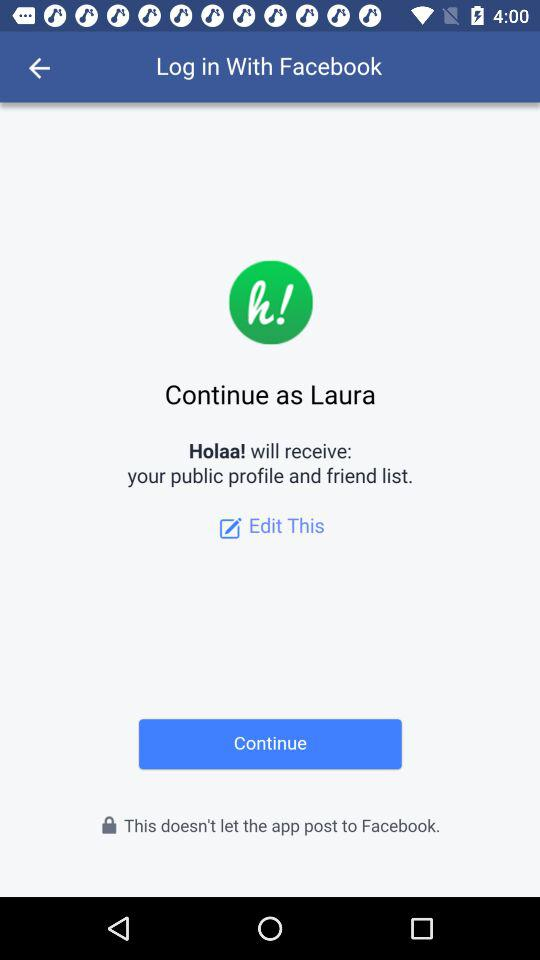Through what application can we log in? You can log in through "Facebook". 